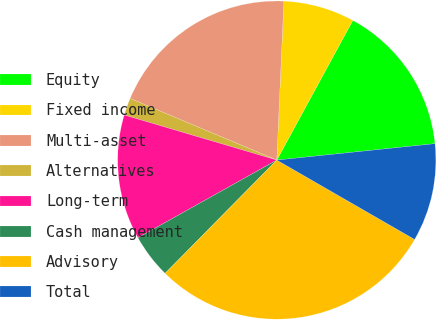Convert chart. <chart><loc_0><loc_0><loc_500><loc_500><pie_chart><fcel>Equity<fcel>Fixed income<fcel>Multi-asset<fcel>Alternatives<fcel>Long-term<fcel>Cash management<fcel>Advisory<fcel>Total<nl><fcel>15.42%<fcel>7.22%<fcel>19.38%<fcel>1.76%<fcel>12.69%<fcel>4.49%<fcel>29.07%<fcel>9.96%<nl></chart> 